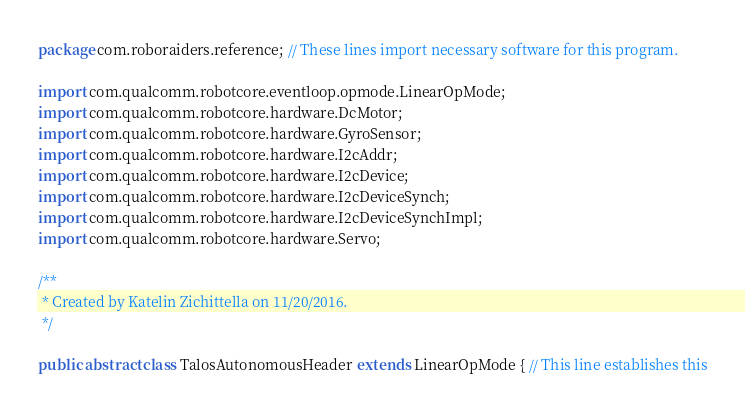<code> <loc_0><loc_0><loc_500><loc_500><_Java_>package com.roboraiders.reference; // These lines import necessary software for this program.

import com.qualcomm.robotcore.eventloop.opmode.LinearOpMode;
import com.qualcomm.robotcore.hardware.DcMotor;
import com.qualcomm.robotcore.hardware.GyroSensor;
import com.qualcomm.robotcore.hardware.I2cAddr;
import com.qualcomm.robotcore.hardware.I2cDevice;
import com.qualcomm.robotcore.hardware.I2cDeviceSynch;
import com.qualcomm.robotcore.hardware.I2cDeviceSynchImpl;
import com.qualcomm.robotcore.hardware.Servo;

/**
 * Created by Katelin Zichittella on 11/20/2016.
 */

public abstract class TalosAutonomousHeader extends LinearOpMode { // This line establishes this</code> 